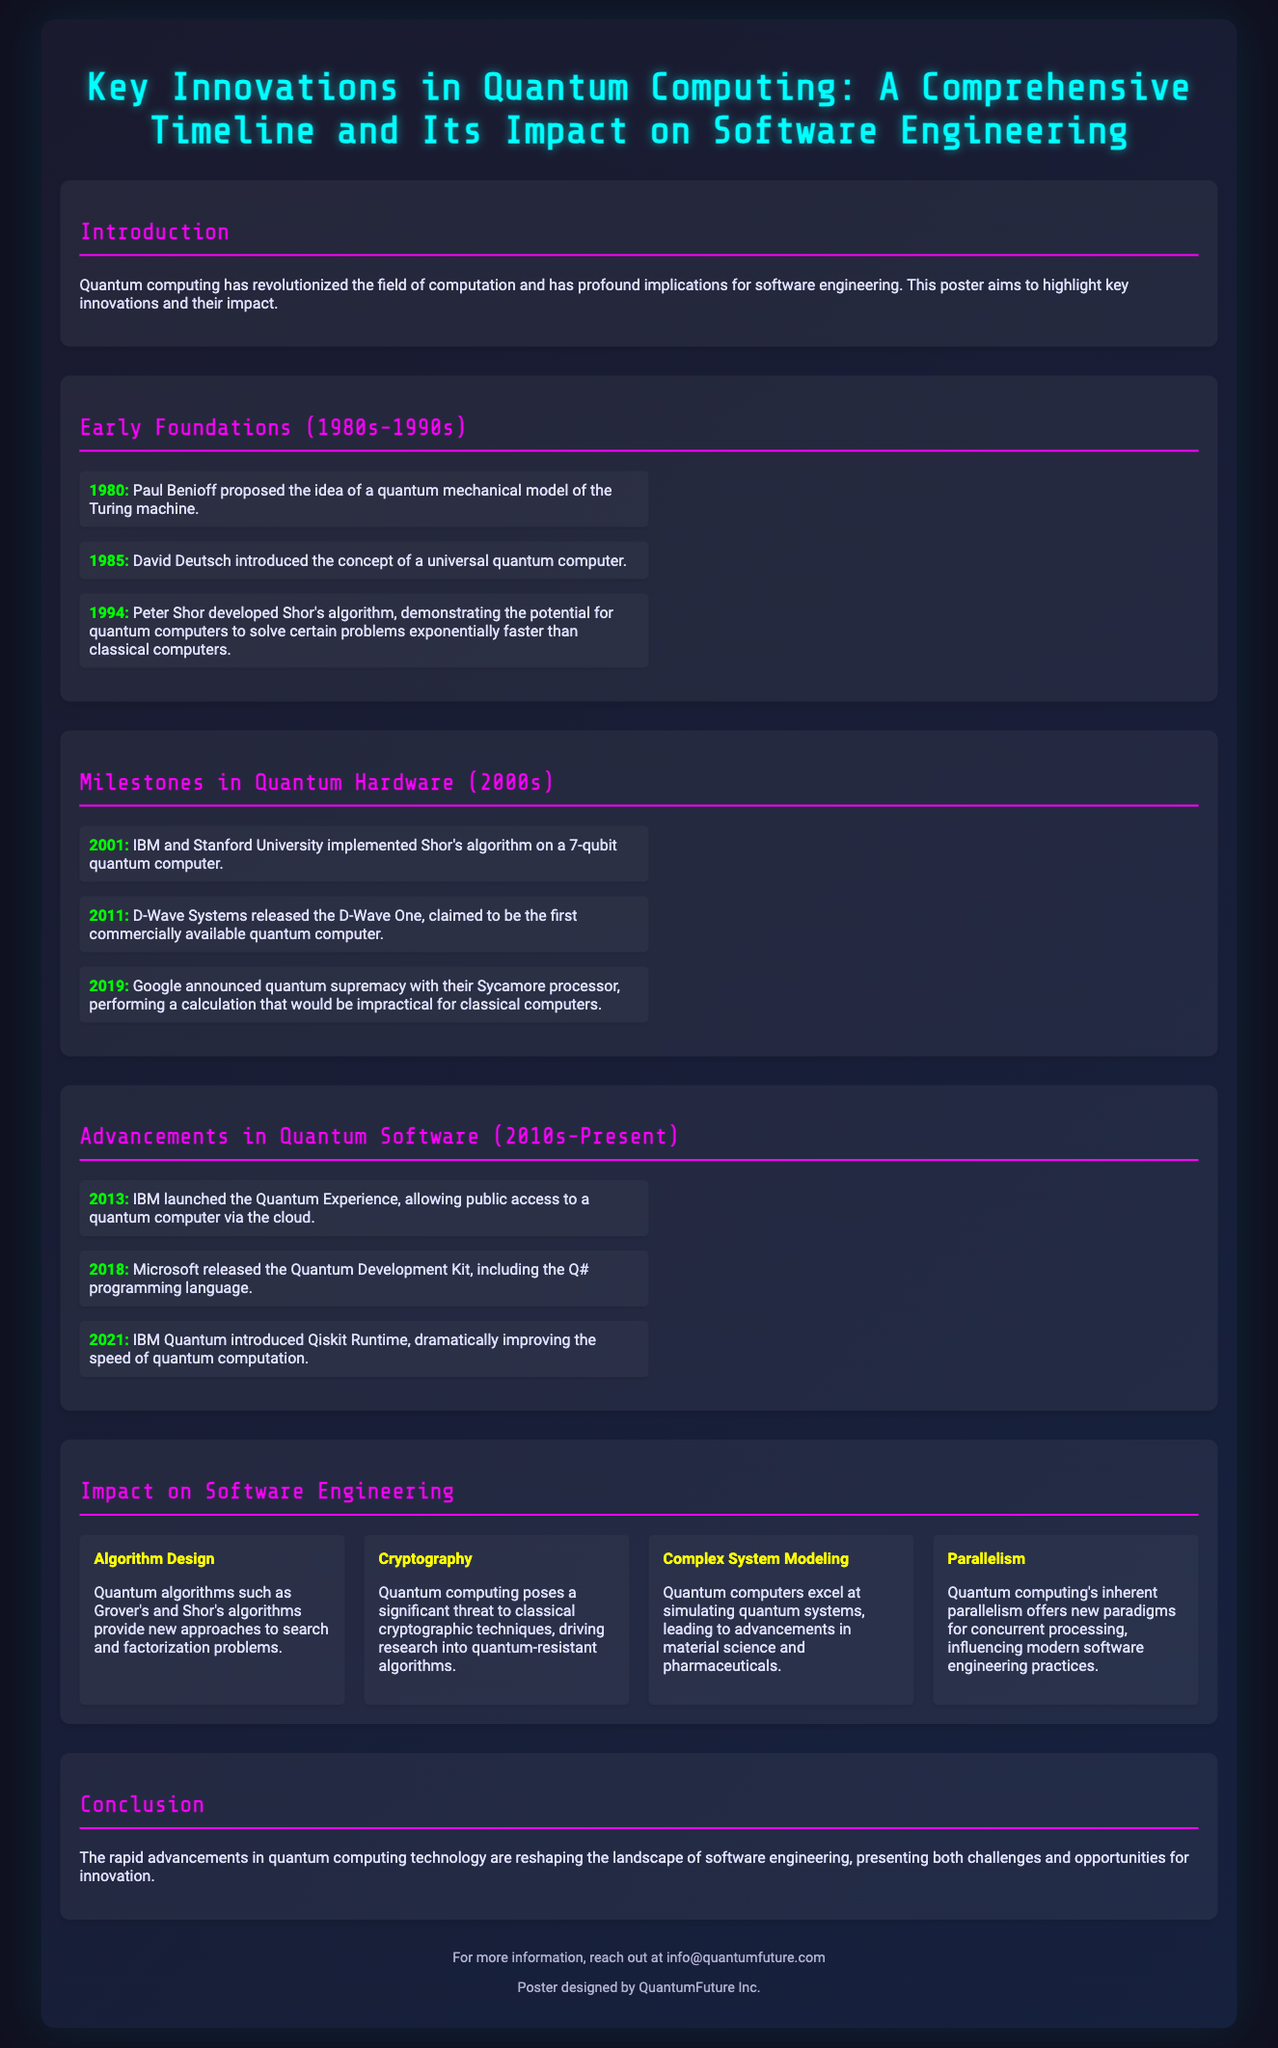What year did Paul Benioff propose a quantum mechanical model of the Turing machine? Paul Benioff's proposal is noted as occurring in 1980 in the timeline section of the document.
Answer: 1980 Who introduced the concept of a universal quantum computer? The timeline indicates that David Deutsch introduced this concept in 1985.
Answer: David Deutsch What algorithm did Peter Shor develop in 1994? Shor's algorithm is specifically mentioned as having been developed by Peter Shor in that year.
Answer: Shor's algorithm Which company released the D-Wave One in 2011? The document states that D-Wave Systems released the D-Wave One, which is a key milestone.
Answer: D-Wave Systems What significant quantum computing achievement did Google announce in 2019? The timeline highlights that Google announced quantum supremacy with their Sycamore processor that year.
Answer: Quantum supremacy In what year did IBM launch the Quantum Experience? The document specifies that the launch of the Quantum Experience by IBM occurred in 2013.
Answer: 2013 What technology poses a threat to classical cryptographic techniques? The impact section mentions that quantum computing poses a significant threat to these techniques.
Answer: Quantum computing Which programming language was included in Microsoft’s Quantum Development Kit? The document includes Q# as the programming language featured in the Quantum Development Kit.
Answer: Q# What aspect of software engineering is influenced by quantum computing's inherent parallelism? The impact section suggests that this parallelism influences modern software engineering practices.
Answer: Modern software engineering practices 